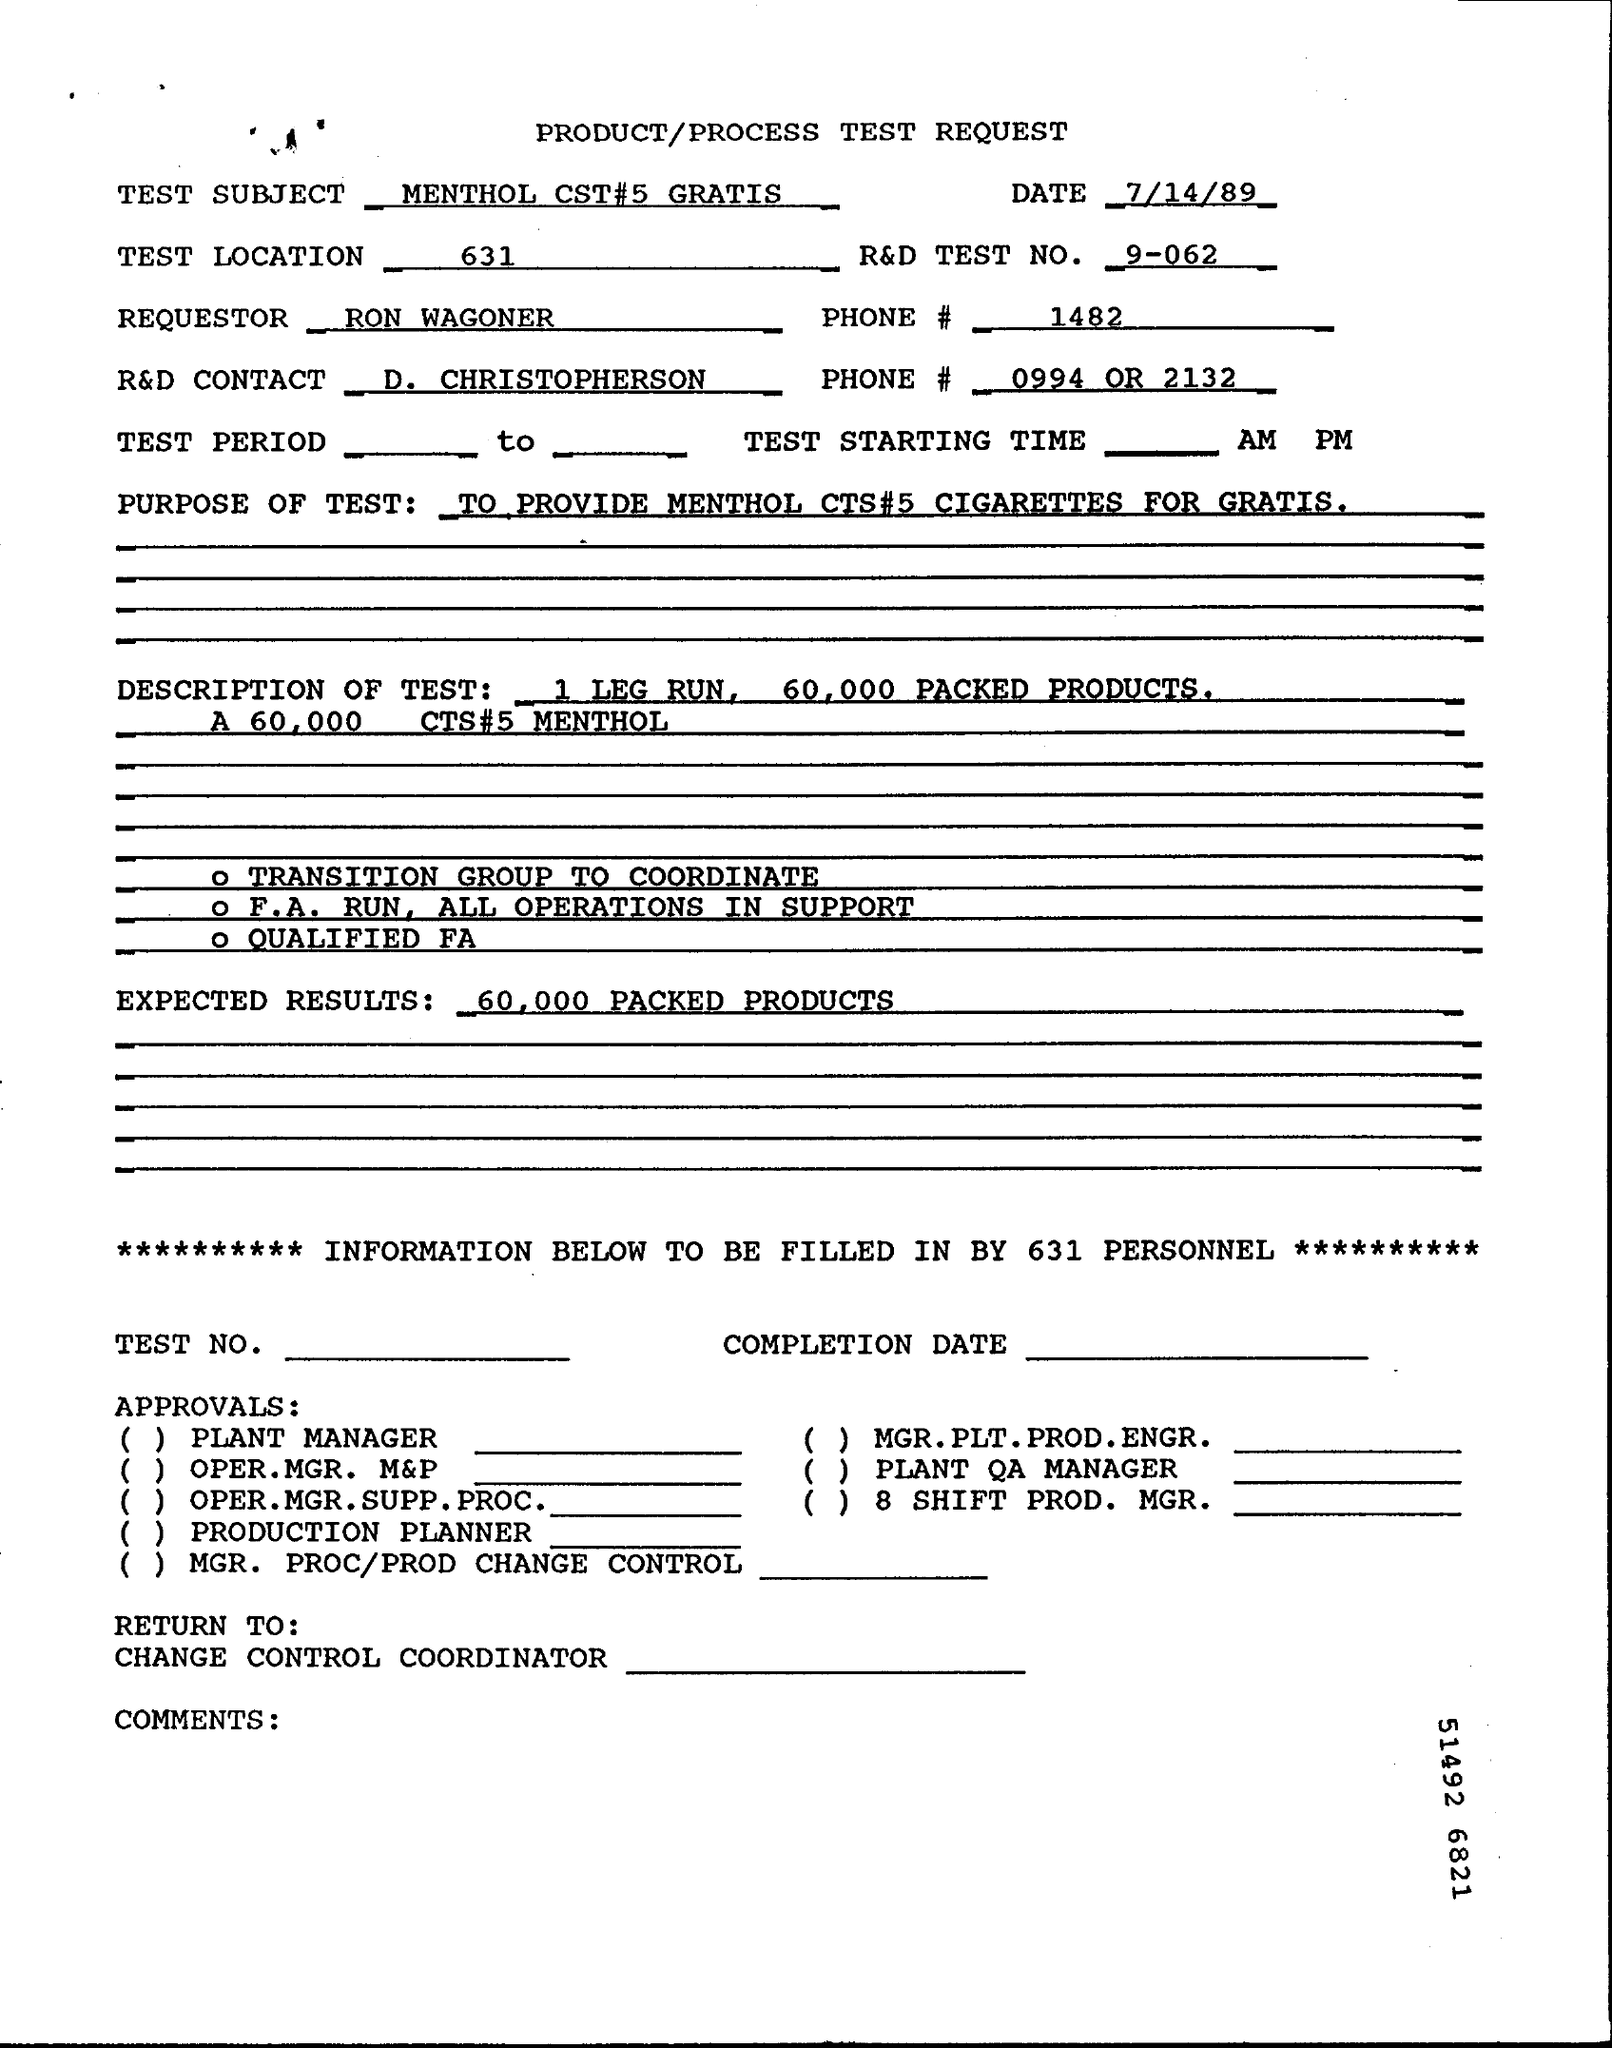What is the document title?
Your response must be concise. PRODUCT/PROCESS TEST REQUEST. What is the test subject?
Your answer should be compact. MENTHOL CST#5 GRATIS. When is the document dated?
Your response must be concise. 7/14/89. Which is the test location?
Provide a succinct answer. 631. What is the R&D TEST NO.?
Provide a succinct answer. 9-062. Who is the requestor?
Your answer should be compact. RON WAGONER. Who is the R&D CONTACT?
Give a very brief answer. D. CHRISTOPHERSON. What are the expected results?
Provide a short and direct response. 60,000 packed products. 